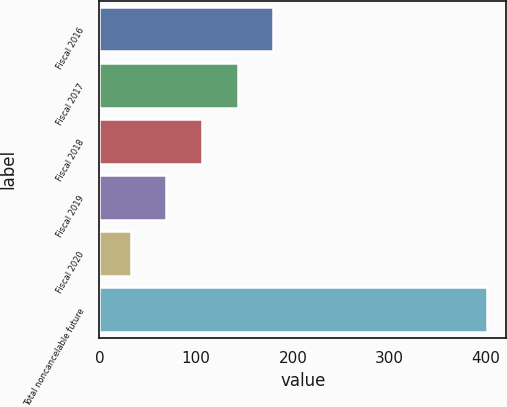Convert chart. <chart><loc_0><loc_0><loc_500><loc_500><bar_chart><fcel>Fiscal 2016<fcel>Fiscal 2017<fcel>Fiscal 2018<fcel>Fiscal 2019<fcel>Fiscal 2020<fcel>Total noncancelable future<nl><fcel>179.64<fcel>142.83<fcel>106.02<fcel>69.21<fcel>32.4<fcel>400.5<nl></chart> 